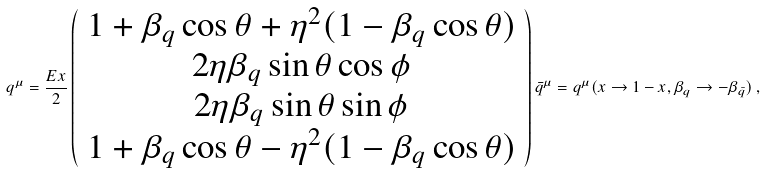Convert formula to latex. <formula><loc_0><loc_0><loc_500><loc_500>q ^ { \mu } = \frac { E x } { 2 } \left ( \begin{array} { c } 1 + \beta _ { q } \cos \theta + \eta ^ { 2 } ( 1 - \beta _ { q } \cos \theta ) \\ 2 \eta \beta _ { q } \sin \theta \cos \phi \\ 2 \eta \beta _ { q } \sin \theta \sin \phi \\ 1 + \beta _ { q } \cos \theta - \eta ^ { 2 } ( 1 - \beta _ { q } \cos \theta ) \end{array} \right ) { \bar { q } } ^ { \mu } = q ^ { \mu } ( x \to 1 - x , \beta _ { q } \to - \beta _ { \bar { q } } ) \, ,</formula> 